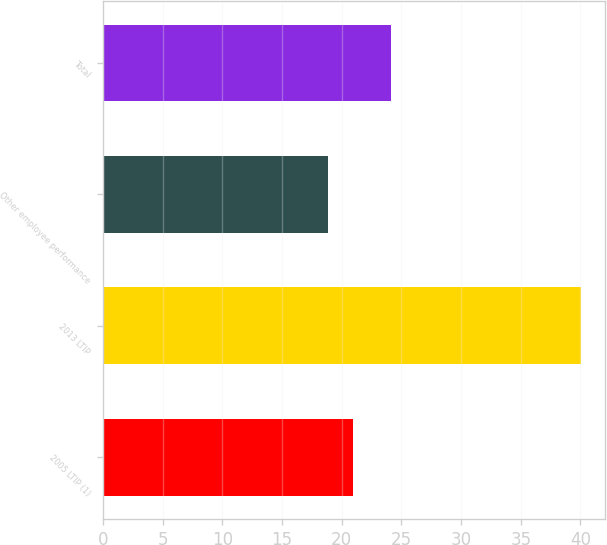<chart> <loc_0><loc_0><loc_500><loc_500><bar_chart><fcel>2005 LTIP (1)<fcel>2013 LTIP<fcel>Other employee performance<fcel>Total<nl><fcel>20.97<fcel>40.02<fcel>18.85<fcel>24.14<nl></chart> 